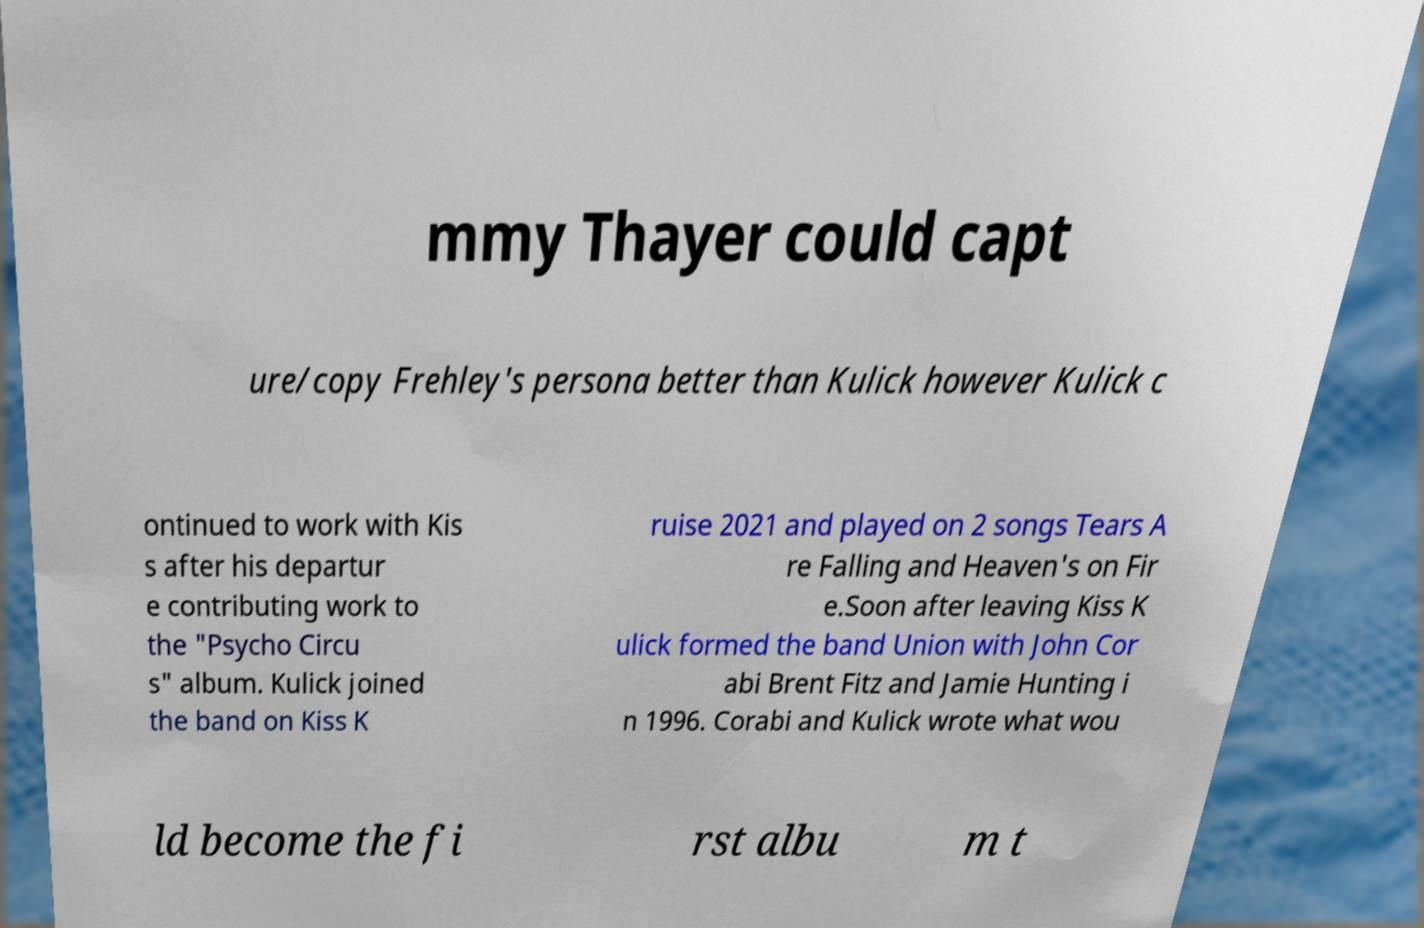Can you read and provide the text displayed in the image?This photo seems to have some interesting text. Can you extract and type it out for me? mmy Thayer could capt ure/copy Frehley's persona better than Kulick however Kulick c ontinued to work with Kis s after his departur e contributing work to the "Psycho Circu s" album. Kulick joined the band on Kiss K ruise 2021 and played on 2 songs Tears A re Falling and Heaven's on Fir e.Soon after leaving Kiss K ulick formed the band Union with John Cor abi Brent Fitz and Jamie Hunting i n 1996. Corabi and Kulick wrote what wou ld become the fi rst albu m t 